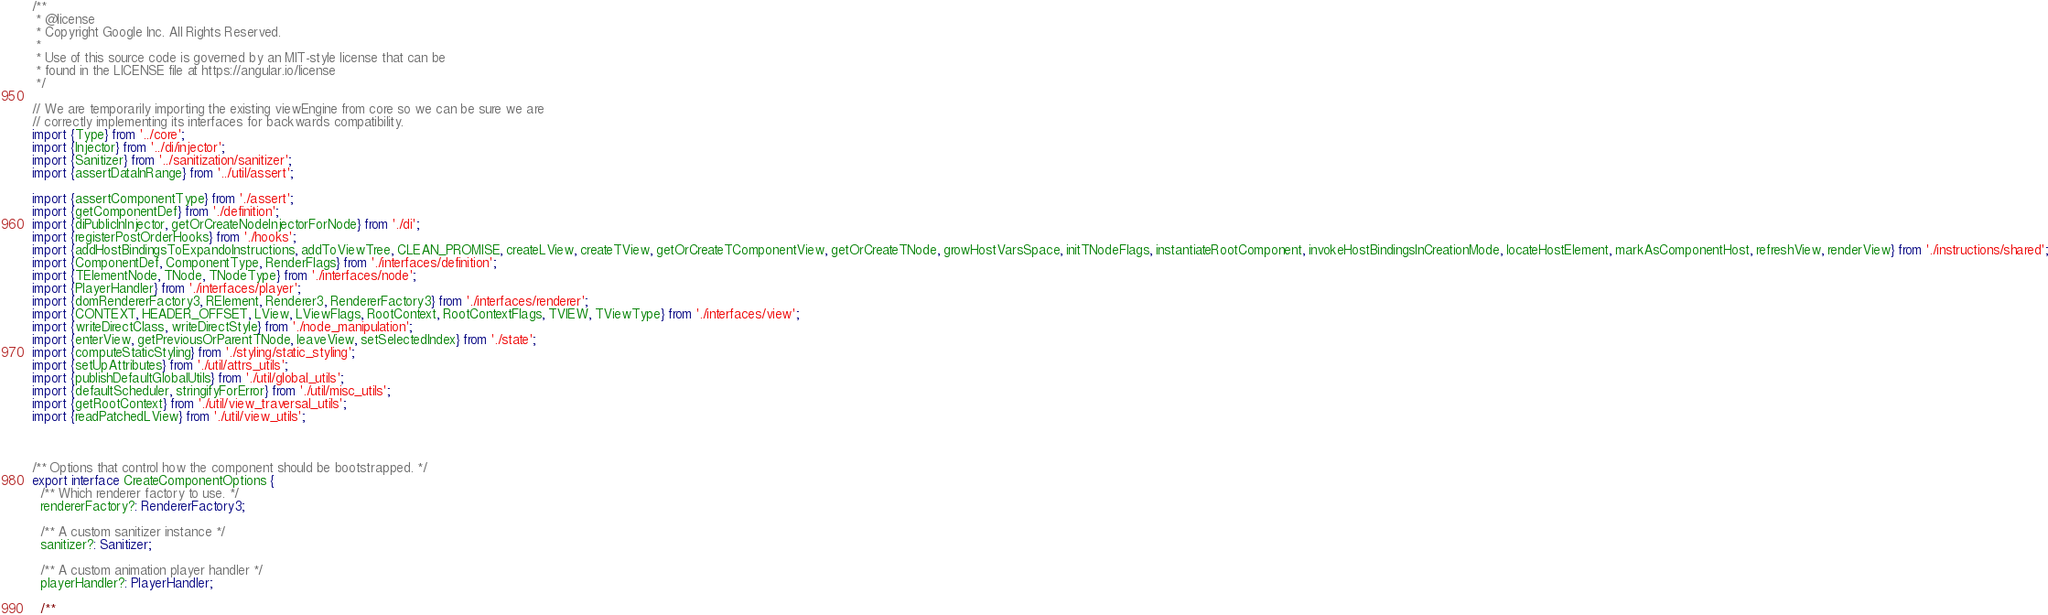Convert code to text. <code><loc_0><loc_0><loc_500><loc_500><_TypeScript_>/**
 * @license
 * Copyright Google Inc. All Rights Reserved.
 *
 * Use of this source code is governed by an MIT-style license that can be
 * found in the LICENSE file at https://angular.io/license
 */

// We are temporarily importing the existing viewEngine from core so we can be sure we are
// correctly implementing its interfaces for backwards compatibility.
import {Type} from '../core';
import {Injector} from '../di/injector';
import {Sanitizer} from '../sanitization/sanitizer';
import {assertDataInRange} from '../util/assert';

import {assertComponentType} from './assert';
import {getComponentDef} from './definition';
import {diPublicInInjector, getOrCreateNodeInjectorForNode} from './di';
import {registerPostOrderHooks} from './hooks';
import {addHostBindingsToExpandoInstructions, addToViewTree, CLEAN_PROMISE, createLView, createTView, getOrCreateTComponentView, getOrCreateTNode, growHostVarsSpace, initTNodeFlags, instantiateRootComponent, invokeHostBindingsInCreationMode, locateHostElement, markAsComponentHost, refreshView, renderView} from './instructions/shared';
import {ComponentDef, ComponentType, RenderFlags} from './interfaces/definition';
import {TElementNode, TNode, TNodeType} from './interfaces/node';
import {PlayerHandler} from './interfaces/player';
import {domRendererFactory3, RElement, Renderer3, RendererFactory3} from './interfaces/renderer';
import {CONTEXT, HEADER_OFFSET, LView, LViewFlags, RootContext, RootContextFlags, TVIEW, TViewType} from './interfaces/view';
import {writeDirectClass, writeDirectStyle} from './node_manipulation';
import {enterView, getPreviousOrParentTNode, leaveView, setSelectedIndex} from './state';
import {computeStaticStyling} from './styling/static_styling';
import {setUpAttributes} from './util/attrs_utils';
import {publishDefaultGlobalUtils} from './util/global_utils';
import {defaultScheduler, stringifyForError} from './util/misc_utils';
import {getRootContext} from './util/view_traversal_utils';
import {readPatchedLView} from './util/view_utils';



/** Options that control how the component should be bootstrapped. */
export interface CreateComponentOptions {
  /** Which renderer factory to use. */
  rendererFactory?: RendererFactory3;

  /** A custom sanitizer instance */
  sanitizer?: Sanitizer;

  /** A custom animation player handler */
  playerHandler?: PlayerHandler;

  /**</code> 